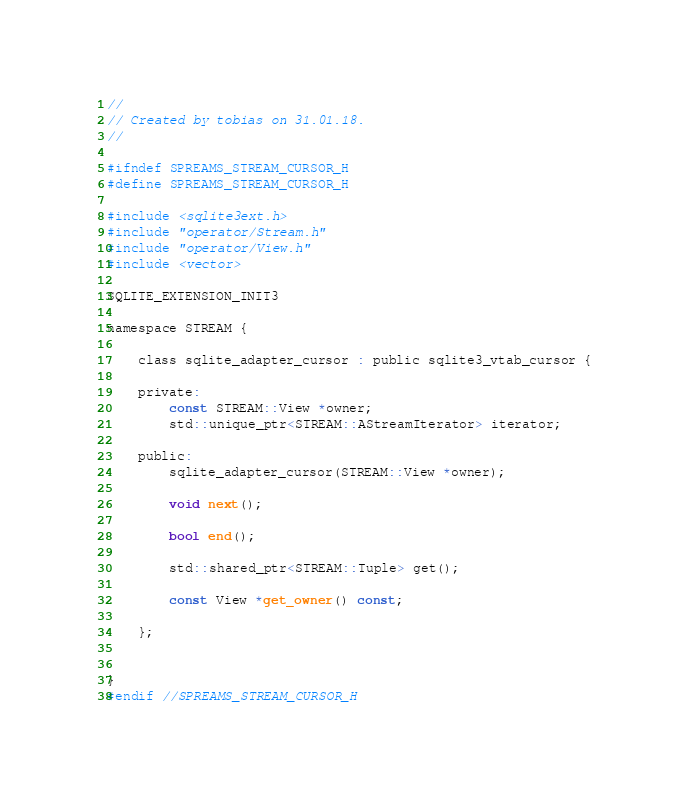Convert code to text. <code><loc_0><loc_0><loc_500><loc_500><_C_>//
// Created by tobias on 31.01.18.
//

#ifndef SPREAMS_STREAM_CURSOR_H
#define SPREAMS_STREAM_CURSOR_H

#include <sqlite3ext.h>
#include "operator/Stream.h"
#include "operator/View.h"
#include <vector>

SQLITE_EXTENSION_INIT3

namespace STREAM {

    class sqlite_adapter_cursor : public sqlite3_vtab_cursor {

    private:
        const STREAM::View *owner;
        std::unique_ptr<STREAM::AStreamIterator> iterator;

    public:
        sqlite_adapter_cursor(STREAM::View *owner);

        void next();

        bool end();

        std::shared_ptr<STREAM::Tuple> get();

        const View *get_owner() const;

    };


}
#endif //SPREAMS_STREAM_CURSOR_H
</code> 